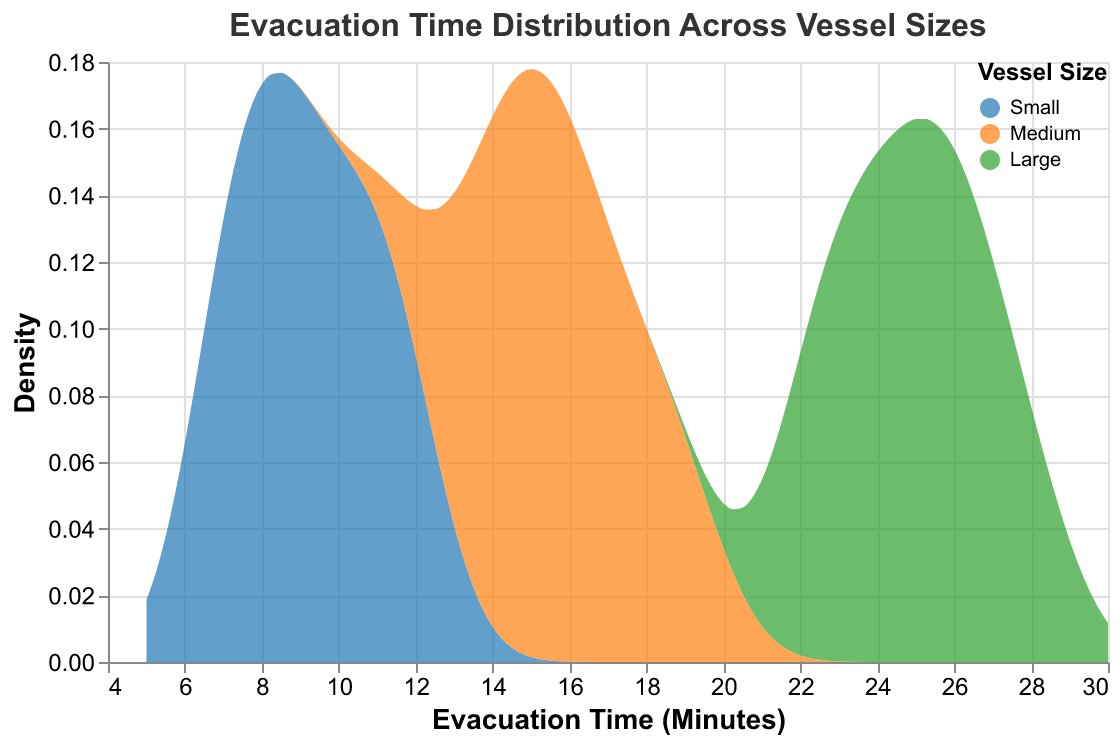What is the title of the figure? The title is written at the top center of the chart and reads "Evacuation Time Distribution Across Vessel Sizes".
Answer: Evacuation Time Distribution Across Vessel Sizes What are the vessel size categories displayed in the figure? The legend at the top-right of the chart shows three categories: "Small", "Medium", and "Large".
Answer: Small, Medium, Large What does the x-axis represent in the figure? The x-axis is labeled "Evacuation Time (Minutes)", indicating it measures the evacuation time in minutes.
Answer: Evacuation Time (Minutes) Which vessel size has the longest evacuation times? By observing the density distributions along the x-axis, the "Large" vessel category has the longest evacuation times, with peaks around 23-28 minutes.
Answer: Large How does the density of evacuation times vary for medium vessels? The medium vessels exhibit a density distribution peaking around 14-19 minutes, indicating most evacuation times fall within this range.
Answer: 14-19 minutes On average, how does the evacuation time for small vessels compare to medium vessels? The peak of the density distribution for "Small" vessels is around 7-12 minutes, while for "Medium" vessels it is around 14-19 minutes, indicating that small vessels have shorter average evacuation times compared to medium vessels.
Answer: Small vessels have shorter average evacuation times What vessel size has the highest density for evacuation times at around 10 minutes? The small vessel category has the highest density in the distribution around 10 minutes.
Answer: Small Which vessel size has the broadest range of evacuation times? The large vessel category shows a broader range of evacuation times, distributed roughly between 22 to 28 minutes.
Answer: Large Which vessel size distribution has the highest peak in density? The density peak for the small vessel category is higher than the peaks for medium and large vessels.
Answer: Small How does the shape of the density distribution for large vessels compare to small vessels? The density distribution for large vessels is broader and flatter with a peak around 25 minutes, whereas the small vessels have a narrower, more peaked distribution around 9 minutes.
Answer: Large vessels: broader and flatter; Small vessels: narrow and peaked 